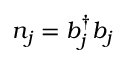Convert formula to latex. <formula><loc_0><loc_0><loc_500><loc_500>{ n } _ { j } = { b } _ { j } ^ { \dagger } { b } _ { j }</formula> 